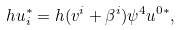<formula> <loc_0><loc_0><loc_500><loc_500>\ h u _ { i } ^ { * } = h ( v ^ { i } + \beta ^ { i } ) \psi ^ { 4 } u ^ { 0 * } ,</formula> 